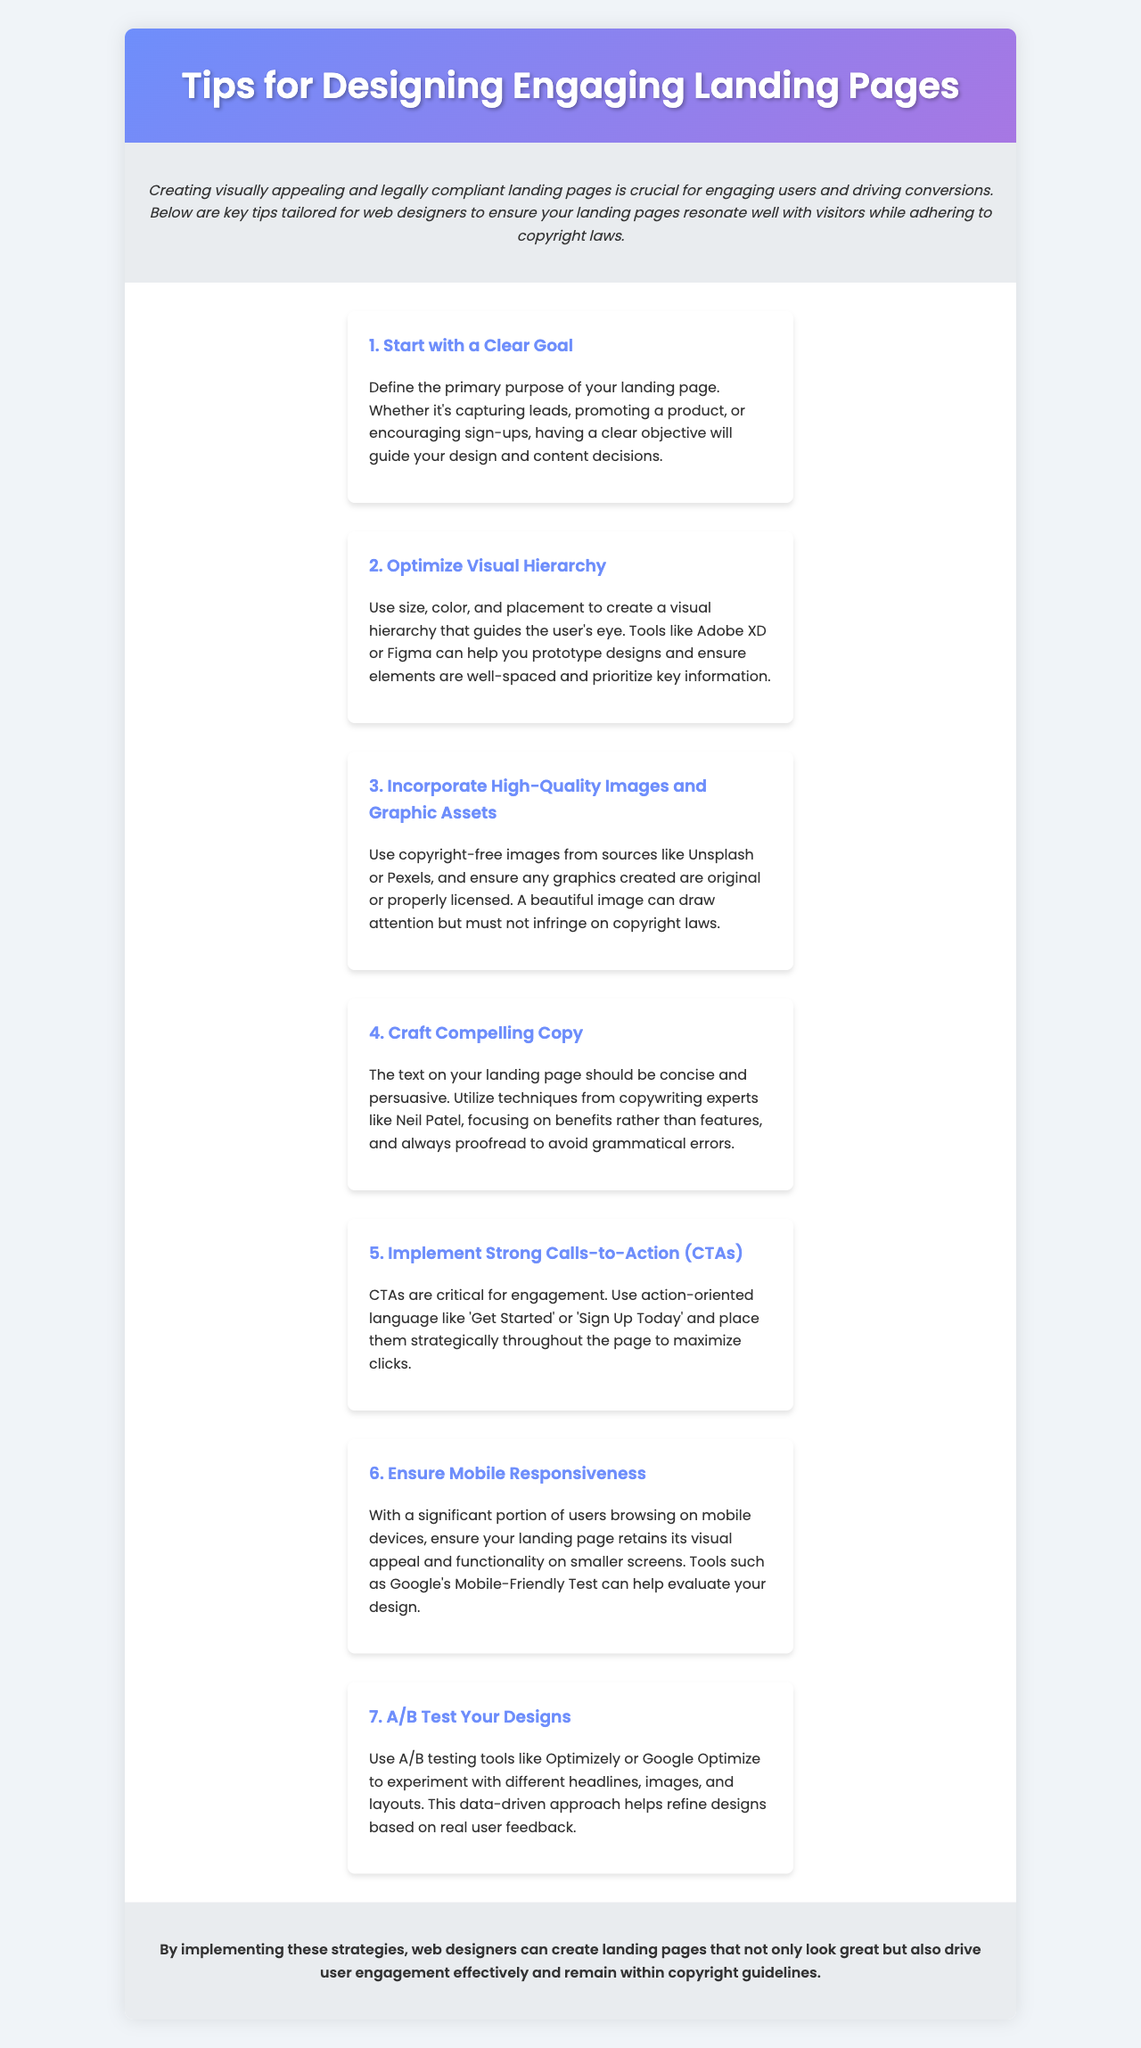What is the title of the brochure? The title is stated in the header of the document.
Answer: Tips for Designing Engaging Landing Pages What is the color scheme used in the brochure? The color scheme is featured prominently in the design description and header.
Answer: Gradient of blue and purple What is the first tip listed? The first tip can be found in the tips section of the document.
Answer: Start with a Clear Goal Name one source for high-quality images mentioned. The document lists sources for images in the tip about incorporating images.
Answer: Unsplash What should the text on the landing page focus on according to the brochure? This information is provided in the tip on crafting compelling copy.
Answer: Benefits rather than features What type of testing tools are suggested for improving design? The brochure includes specific tools for A/B testing in the respective tip.
Answer: Optimizely or Google Optimize What is one feature that ensures mobile responsiveness? The mobile responsiveness tip provides a method to evaluate design effectiveness.
Answer: Google’s Mobile-Friendly Test How should calls-to-action be phrased? The recommended phrasing for CTAs is mentioned in the respective tip.
Answer: Action-oriented language In which section of the brochure are the visual tips located? The visual tips are contained within a specific section of the document.
Answer: tips-container 